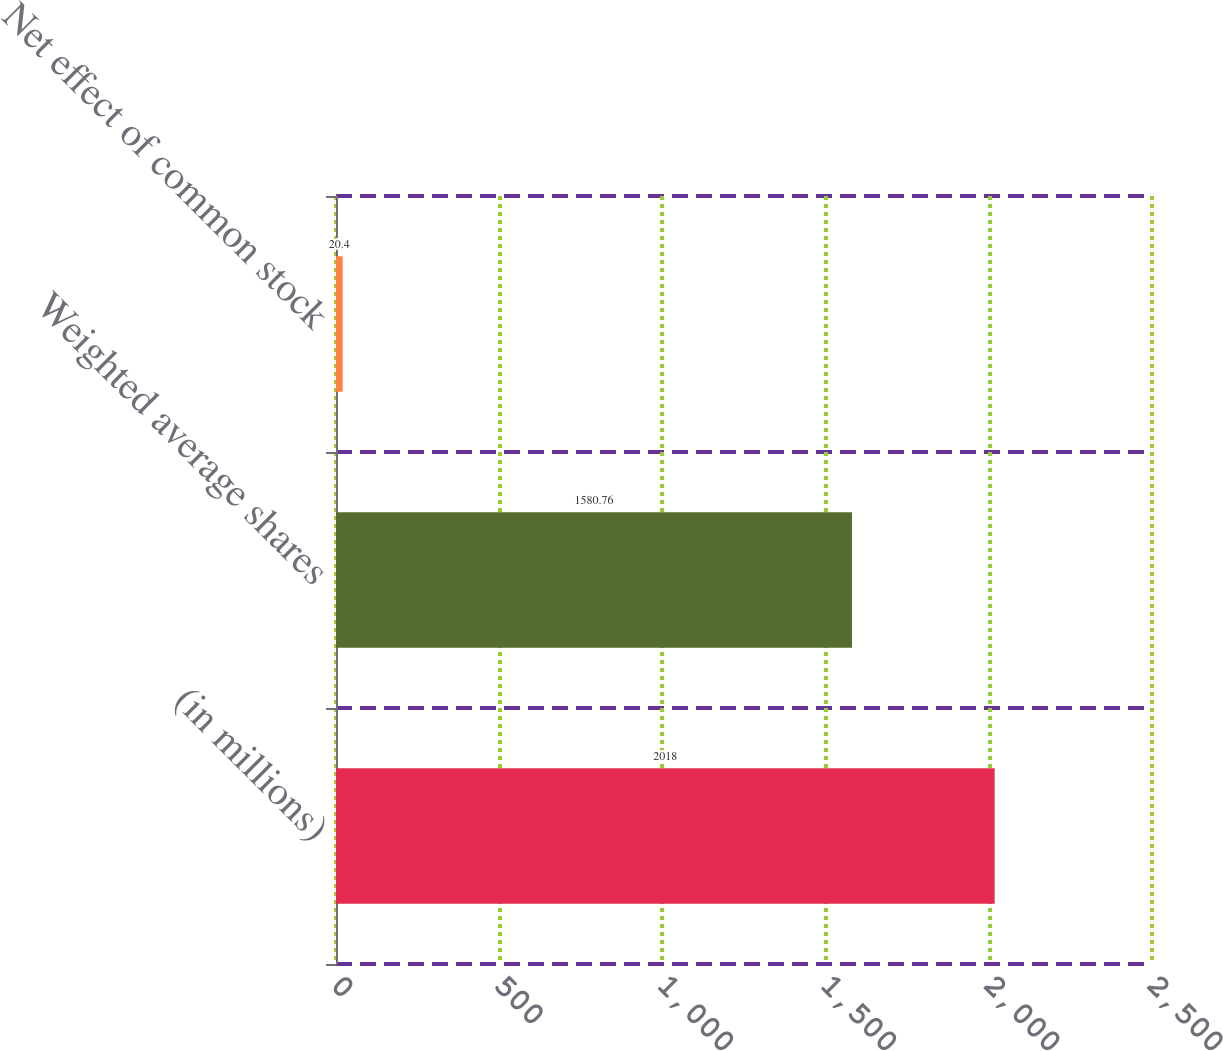Convert chart. <chart><loc_0><loc_0><loc_500><loc_500><bar_chart><fcel>(in millions)<fcel>Weighted average shares<fcel>Net effect of common stock<nl><fcel>2018<fcel>1580.76<fcel>20.4<nl></chart> 